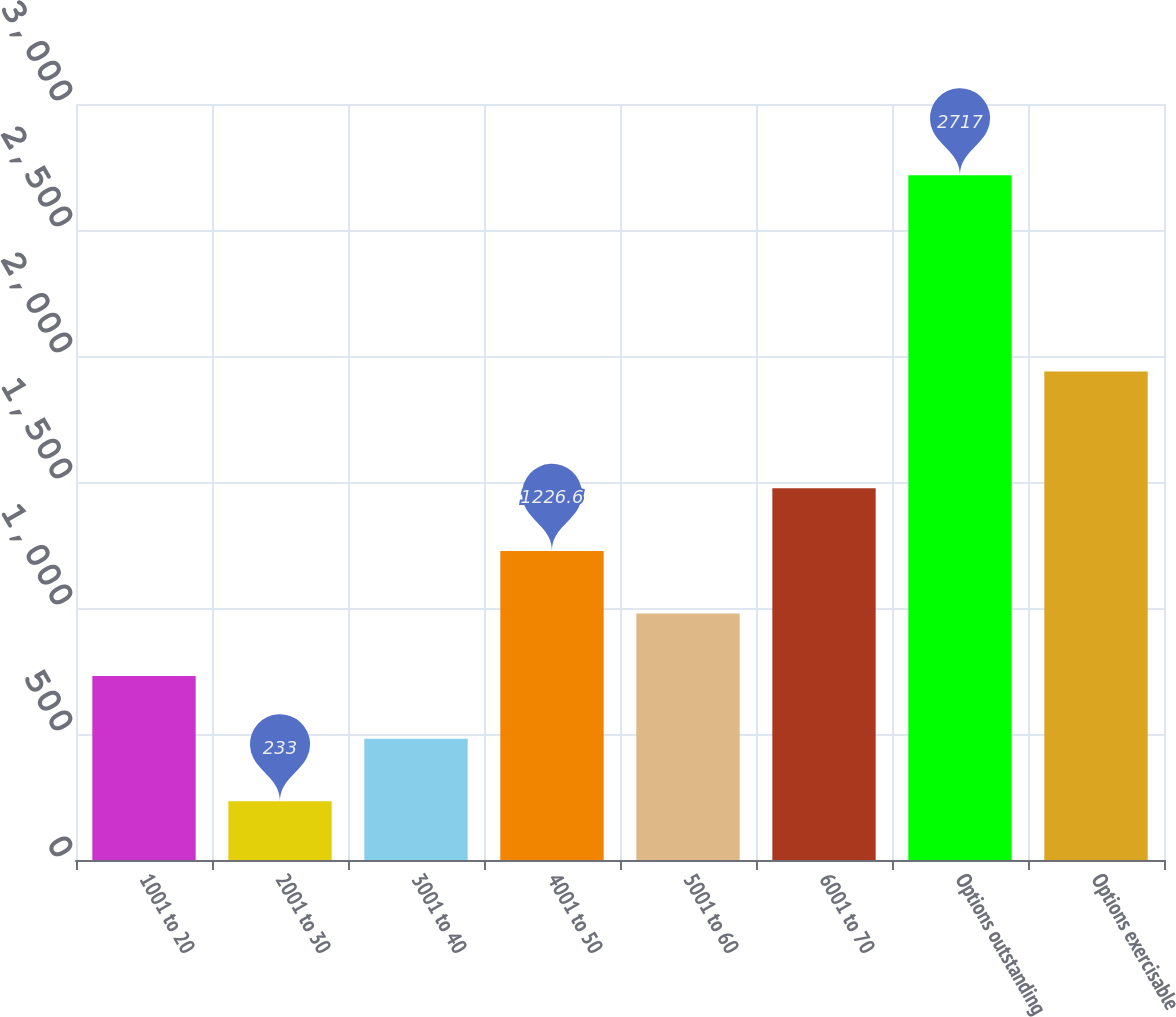Convert chart. <chart><loc_0><loc_0><loc_500><loc_500><bar_chart><fcel>1001 to 20<fcel>2001 to 30<fcel>3001 to 40<fcel>4001 to 50<fcel>5001 to 60<fcel>6001 to 70<fcel>Options outstanding<fcel>Options exercisable<nl><fcel>729.8<fcel>233<fcel>481.4<fcel>1226.6<fcel>978.2<fcel>1475<fcel>2717<fcel>1938<nl></chart> 